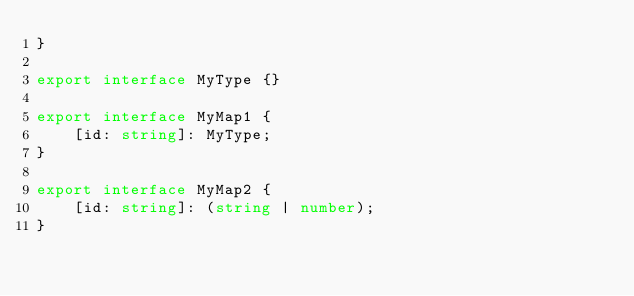Convert code to text. <code><loc_0><loc_0><loc_500><loc_500><_TypeScript_>}

export interface MyType {}

export interface MyMap1 {
    [id: string]: MyType;
}

export interface MyMap2 {
    [id: string]: (string | number);
}
</code> 